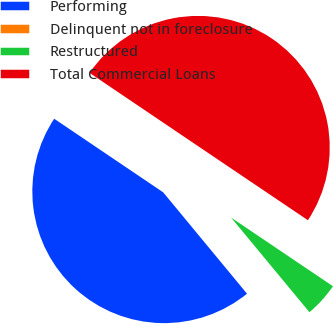Convert chart. <chart><loc_0><loc_0><loc_500><loc_500><pie_chart><fcel>Performing<fcel>Delinquent not in foreclosure<fcel>Restructured<fcel>Total Commercial Loans<nl><fcel>45.45%<fcel>0.01%<fcel>4.55%<fcel>49.99%<nl></chart> 